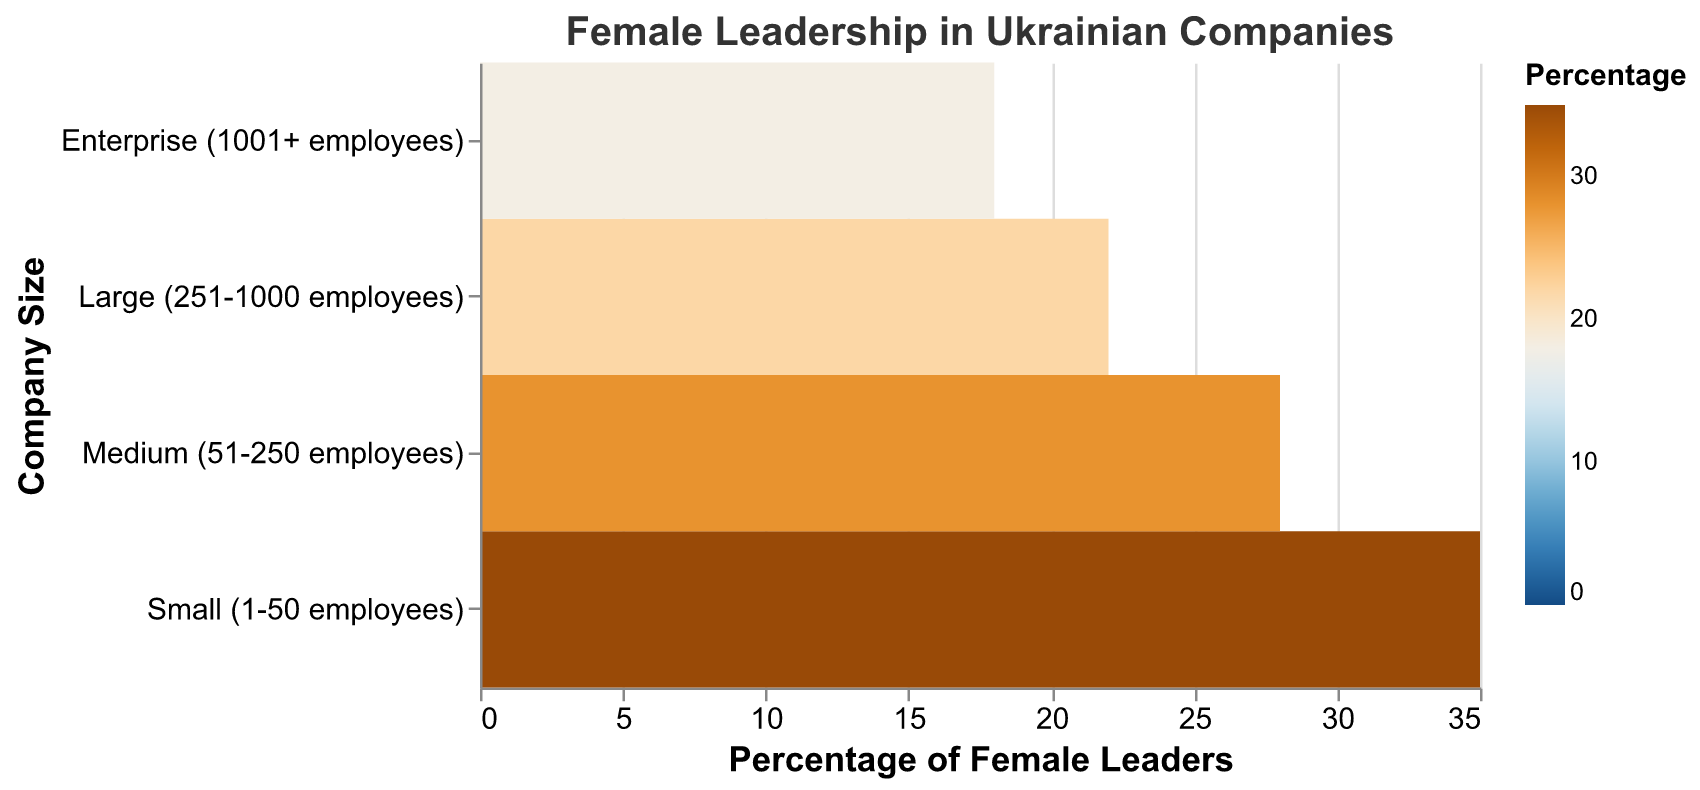What's the title of the figure? The title is displayed at the top of the figure. It reads "Female Leadership in Ukrainian Companies".
Answer: Female Leadership in Ukrainian Companies What does the color legend represent? The color legend is found on the right side and explains that colors represent the "Percentage of Female Leaders" in the figure.
Answer: Percentage of Female Leaders How many categories of company sizes are there? On the y-axis of the heatmap, there are four categories listed: Small (1-50 employees), Medium (51-250 employees), Large (251-1000 employees), and Enterprise (1001+ employees).
Answer: Four Which company size has the highest percentage of female leaders? The color with the highest shading indicates the highest value. The darkest blue represents Small companies, and their position on the x-axis shows a percentage of 35.
Answer: Small (1-50 employees) What is the percentage of female leaders in enterprises? To find this, look at the "Enterprise (1001+ employees)" row and move horizontally to see the "Percentage of Female Leaders", which is indicated to be 18%.
Answer: 18% What is the difference in the percentage of female leaders between small and large companies? The percentage of female leaders in Small companies is 35%, while it is 22% in Large companies. Subtract 22 from 35 to get the difference, 35 - 22 = 13.
Answer: 13% Which company size category shows the least percentage of female leaders and what's the value? The lightest color on the visual represents the lowest percentage, which corresponds to the Enterprise category at 18% on the x-axis.
Answer: Enterprise, 18% How do the percentages of female leaders in medium and large companies compare? The color for Medium companies is a lighter blue than Small and darker than Large. Medium companies have a percentage of 28%, while Large companies show 22%. Since 28 > 22, Medium companies have a higher percentage than Large.
Answer: Medium has a higher percentage than Large What’s the average percentage of female leaders across all company sizes? The percentages are 35%, 28%, 22%, and 18%. Sum them up: 35 + 28 + 22 + 18 = 103. Divide by the number of company sizes (4) to get the average, 103 / 4 = 25.75.
Answer: 25.75% Describe the color scale of the heatmap. The heatmap uses a blueorange color scheme. The shading transitions from lighter colors (lower percentages) to darker blue colors (higher percentages), scaled between 0 to 35%.
Answer: Blueorange scale from 0 to 35% 